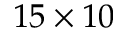<formula> <loc_0><loc_0><loc_500><loc_500>1 5 \times 1 0</formula> 